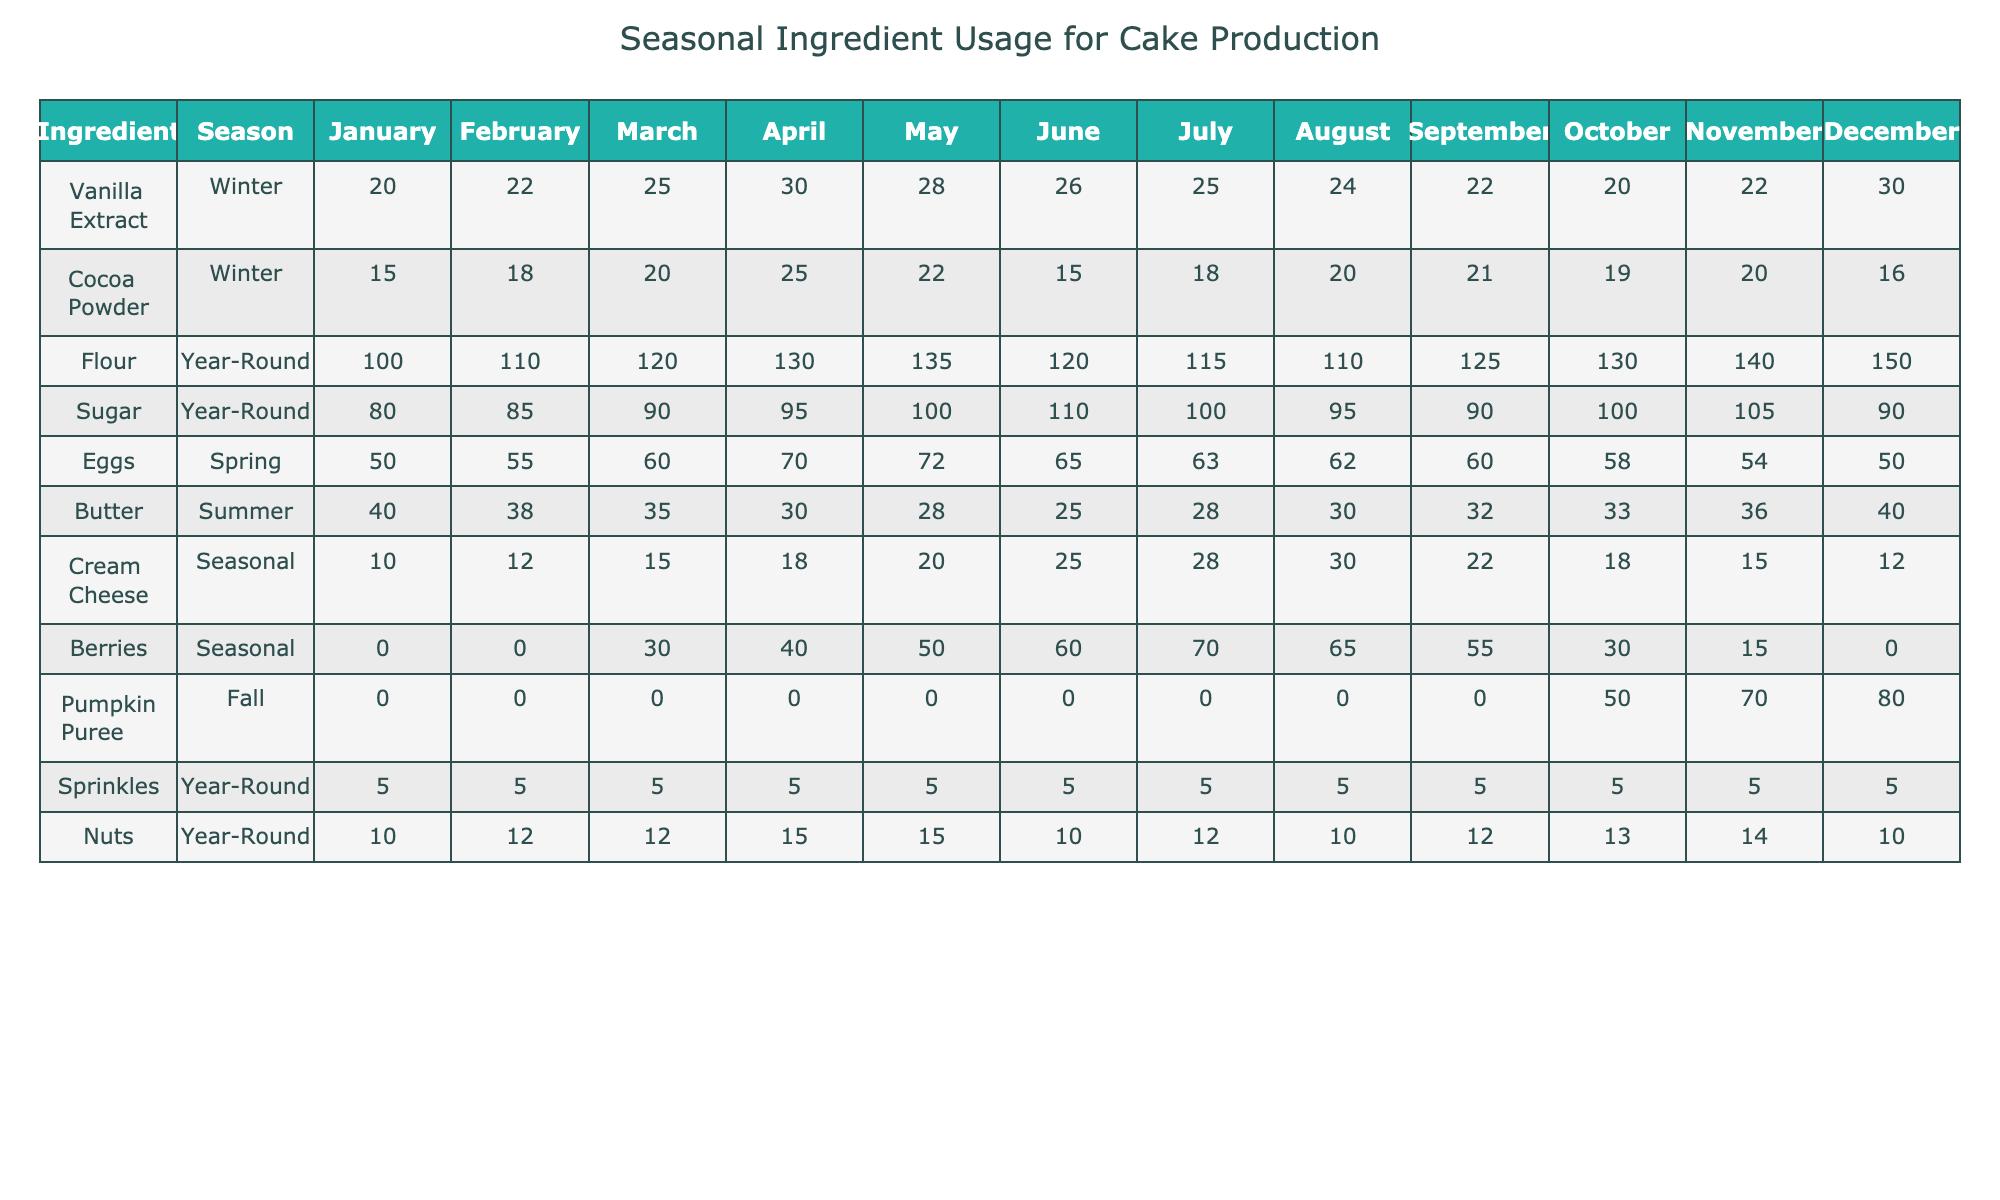What is the highest usage of Cocoa Powder in a month? The table shows the usage of Cocoa Powder for each month. The highest usage is in April at 25.
Answer: 25 In which season is Butter usage lowest, and what is the value? The table indicates that Butter is used in the summer season, with the lowest usage recorded in July at 25.
Answer: 25 What is the total amount of Eggs used from March to May? The Egg usage for March is 60, for April is 70, and for May is 72. To find the total, sum these values: 60 + 70 + 72 = 202.
Answer: 202 Is the usage of Cream Cheese higher in the summer than in the winter? The table shows that Cream Cheese usage is 25 in June and 12 in December, which indicates that summer usage is indeed higher than winter usage of 12.
Answer: Yes What is the average monthly usage of Berries from April to July? Berries usage for April is 40, May is 50, June is 60, and July is 70. The total is 40 + 50 + 60 + 70 = 220, and there are 4 months, so the average is 220 / 4 = 55.
Answer: 55 How much more Sugar is used in May compared to January? The table shows that Sugar usage is 100 in January and 100 in May. The difference is 100 - 80 = 20.
Answer: 20 What is the total amount of Flour used from January to December? The Flour usage is a constant amount year-round. From the table, the sum from January to December is 100 + 110 + 120 + 130 + 135 + 120 + 115 + 110 + 125 + 130 + 140 + 150 = 1,575.
Answer: 1575 During which season is Vanilla Extract used the most, and what is the peak usage? The Vanilla Extract is used most in the winter season, with the peak usage in April at 30.
Answer: 30 Is it true that the usage of Nuts is consistent throughout the year? Looking at the table, we observe that the usage of Nuts varies each month: it ranges from 10 to 15. Hence, it is not consistent.
Answer: No What is the monthly trend of Pumpkin Puree usage from September to December? The Pumpkin Puree usage shows 0 in September, October, and November, then peaks in December at 80. This indicates a late harvest influence starting in fall.
Answer: Peaks in December 